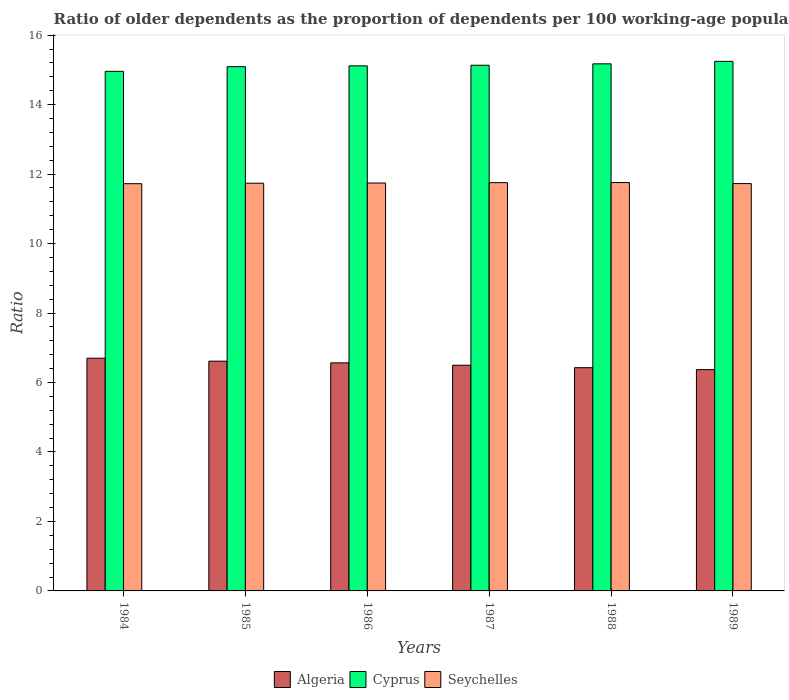How many groups of bars are there?
Offer a terse response. 6. Are the number of bars per tick equal to the number of legend labels?
Your response must be concise. Yes. Are the number of bars on each tick of the X-axis equal?
Provide a short and direct response. Yes. How many bars are there on the 6th tick from the right?
Provide a succinct answer. 3. What is the label of the 1st group of bars from the left?
Offer a terse response. 1984. In how many cases, is the number of bars for a given year not equal to the number of legend labels?
Your response must be concise. 0. What is the age dependency ratio(old) in Seychelles in 1989?
Your answer should be very brief. 11.73. Across all years, what is the maximum age dependency ratio(old) in Seychelles?
Provide a short and direct response. 11.76. Across all years, what is the minimum age dependency ratio(old) in Algeria?
Provide a succinct answer. 6.37. In which year was the age dependency ratio(old) in Cyprus maximum?
Offer a very short reply. 1989. What is the total age dependency ratio(old) in Cyprus in the graph?
Offer a very short reply. 90.72. What is the difference between the age dependency ratio(old) in Seychelles in 1985 and that in 1988?
Keep it short and to the point. -0.02. What is the difference between the age dependency ratio(old) in Seychelles in 1987 and the age dependency ratio(old) in Cyprus in 1985?
Make the answer very short. -3.34. What is the average age dependency ratio(old) in Seychelles per year?
Provide a succinct answer. 11.74. In the year 1989, what is the difference between the age dependency ratio(old) in Seychelles and age dependency ratio(old) in Cyprus?
Provide a short and direct response. -3.52. What is the ratio of the age dependency ratio(old) in Cyprus in 1985 to that in 1987?
Your response must be concise. 1. Is the difference between the age dependency ratio(old) in Seychelles in 1988 and 1989 greater than the difference between the age dependency ratio(old) in Cyprus in 1988 and 1989?
Give a very brief answer. Yes. What is the difference between the highest and the second highest age dependency ratio(old) in Algeria?
Offer a terse response. 0.09. What is the difference between the highest and the lowest age dependency ratio(old) in Cyprus?
Your response must be concise. 0.29. In how many years, is the age dependency ratio(old) in Cyprus greater than the average age dependency ratio(old) in Cyprus taken over all years?
Your answer should be compact. 3. Is the sum of the age dependency ratio(old) in Algeria in 1988 and 1989 greater than the maximum age dependency ratio(old) in Cyprus across all years?
Your response must be concise. No. What does the 1st bar from the left in 1988 represents?
Give a very brief answer. Algeria. What does the 1st bar from the right in 1989 represents?
Ensure brevity in your answer.  Seychelles. Does the graph contain any zero values?
Keep it short and to the point. No. Where does the legend appear in the graph?
Your answer should be very brief. Bottom center. How many legend labels are there?
Your response must be concise. 3. What is the title of the graph?
Keep it short and to the point. Ratio of older dependents as the proportion of dependents per 100 working-age population. Does "OECD members" appear as one of the legend labels in the graph?
Offer a very short reply. No. What is the label or title of the X-axis?
Your response must be concise. Years. What is the label or title of the Y-axis?
Offer a terse response. Ratio. What is the Ratio of Algeria in 1984?
Your answer should be compact. 6.7. What is the Ratio of Cyprus in 1984?
Give a very brief answer. 14.96. What is the Ratio in Seychelles in 1984?
Your answer should be very brief. 11.72. What is the Ratio of Algeria in 1985?
Make the answer very short. 6.61. What is the Ratio of Cyprus in 1985?
Offer a very short reply. 15.09. What is the Ratio of Seychelles in 1985?
Keep it short and to the point. 11.74. What is the Ratio of Algeria in 1986?
Your answer should be very brief. 6.57. What is the Ratio in Cyprus in 1986?
Your answer should be compact. 15.12. What is the Ratio in Seychelles in 1986?
Your response must be concise. 11.74. What is the Ratio in Algeria in 1987?
Your answer should be compact. 6.5. What is the Ratio of Cyprus in 1987?
Ensure brevity in your answer.  15.13. What is the Ratio in Seychelles in 1987?
Keep it short and to the point. 11.75. What is the Ratio of Algeria in 1988?
Give a very brief answer. 6.43. What is the Ratio of Cyprus in 1988?
Make the answer very short. 15.17. What is the Ratio in Seychelles in 1988?
Give a very brief answer. 11.76. What is the Ratio of Algeria in 1989?
Your response must be concise. 6.37. What is the Ratio of Cyprus in 1989?
Provide a succinct answer. 15.25. What is the Ratio in Seychelles in 1989?
Make the answer very short. 11.73. Across all years, what is the maximum Ratio in Algeria?
Your answer should be compact. 6.7. Across all years, what is the maximum Ratio in Cyprus?
Make the answer very short. 15.25. Across all years, what is the maximum Ratio in Seychelles?
Provide a succinct answer. 11.76. Across all years, what is the minimum Ratio in Algeria?
Give a very brief answer. 6.37. Across all years, what is the minimum Ratio in Cyprus?
Make the answer very short. 14.96. Across all years, what is the minimum Ratio in Seychelles?
Your answer should be compact. 11.72. What is the total Ratio of Algeria in the graph?
Offer a very short reply. 39.17. What is the total Ratio in Cyprus in the graph?
Make the answer very short. 90.72. What is the total Ratio of Seychelles in the graph?
Provide a short and direct response. 70.44. What is the difference between the Ratio of Algeria in 1984 and that in 1985?
Ensure brevity in your answer.  0.09. What is the difference between the Ratio in Cyprus in 1984 and that in 1985?
Offer a very short reply. -0.13. What is the difference between the Ratio of Seychelles in 1984 and that in 1985?
Your response must be concise. -0.01. What is the difference between the Ratio of Algeria in 1984 and that in 1986?
Provide a succinct answer. 0.13. What is the difference between the Ratio of Cyprus in 1984 and that in 1986?
Your response must be concise. -0.16. What is the difference between the Ratio in Seychelles in 1984 and that in 1986?
Offer a very short reply. -0.02. What is the difference between the Ratio of Algeria in 1984 and that in 1987?
Your answer should be compact. 0.2. What is the difference between the Ratio in Cyprus in 1984 and that in 1987?
Your answer should be compact. -0.18. What is the difference between the Ratio in Seychelles in 1984 and that in 1987?
Your response must be concise. -0.03. What is the difference between the Ratio of Algeria in 1984 and that in 1988?
Make the answer very short. 0.27. What is the difference between the Ratio in Cyprus in 1984 and that in 1988?
Provide a succinct answer. -0.22. What is the difference between the Ratio in Seychelles in 1984 and that in 1988?
Offer a very short reply. -0.03. What is the difference between the Ratio in Algeria in 1984 and that in 1989?
Make the answer very short. 0.33. What is the difference between the Ratio of Cyprus in 1984 and that in 1989?
Provide a short and direct response. -0.29. What is the difference between the Ratio of Seychelles in 1984 and that in 1989?
Your answer should be very brief. -0. What is the difference between the Ratio of Algeria in 1985 and that in 1986?
Keep it short and to the point. 0.05. What is the difference between the Ratio in Cyprus in 1985 and that in 1986?
Your answer should be very brief. -0.02. What is the difference between the Ratio of Seychelles in 1985 and that in 1986?
Keep it short and to the point. -0.01. What is the difference between the Ratio of Algeria in 1985 and that in 1987?
Your response must be concise. 0.12. What is the difference between the Ratio in Cyprus in 1985 and that in 1987?
Ensure brevity in your answer.  -0.04. What is the difference between the Ratio in Seychelles in 1985 and that in 1987?
Keep it short and to the point. -0.02. What is the difference between the Ratio in Algeria in 1985 and that in 1988?
Offer a terse response. 0.19. What is the difference between the Ratio in Cyprus in 1985 and that in 1988?
Provide a short and direct response. -0.08. What is the difference between the Ratio of Seychelles in 1985 and that in 1988?
Your answer should be compact. -0.02. What is the difference between the Ratio of Algeria in 1985 and that in 1989?
Provide a short and direct response. 0.24. What is the difference between the Ratio of Cyprus in 1985 and that in 1989?
Keep it short and to the point. -0.15. What is the difference between the Ratio in Seychelles in 1985 and that in 1989?
Offer a terse response. 0.01. What is the difference between the Ratio in Algeria in 1986 and that in 1987?
Provide a short and direct response. 0.07. What is the difference between the Ratio of Cyprus in 1986 and that in 1987?
Make the answer very short. -0.02. What is the difference between the Ratio in Seychelles in 1986 and that in 1987?
Keep it short and to the point. -0.01. What is the difference between the Ratio in Algeria in 1986 and that in 1988?
Your answer should be very brief. 0.14. What is the difference between the Ratio of Cyprus in 1986 and that in 1988?
Make the answer very short. -0.06. What is the difference between the Ratio of Seychelles in 1986 and that in 1988?
Make the answer very short. -0.01. What is the difference between the Ratio of Algeria in 1986 and that in 1989?
Ensure brevity in your answer.  0.19. What is the difference between the Ratio of Cyprus in 1986 and that in 1989?
Ensure brevity in your answer.  -0.13. What is the difference between the Ratio of Seychelles in 1986 and that in 1989?
Offer a very short reply. 0.02. What is the difference between the Ratio in Algeria in 1987 and that in 1988?
Ensure brevity in your answer.  0.07. What is the difference between the Ratio in Cyprus in 1987 and that in 1988?
Offer a very short reply. -0.04. What is the difference between the Ratio of Seychelles in 1987 and that in 1988?
Your response must be concise. -0. What is the difference between the Ratio of Algeria in 1987 and that in 1989?
Your answer should be compact. 0.13. What is the difference between the Ratio of Cyprus in 1987 and that in 1989?
Provide a short and direct response. -0.11. What is the difference between the Ratio of Seychelles in 1987 and that in 1989?
Provide a succinct answer. 0.03. What is the difference between the Ratio in Algeria in 1988 and that in 1989?
Ensure brevity in your answer.  0.06. What is the difference between the Ratio of Cyprus in 1988 and that in 1989?
Give a very brief answer. -0.07. What is the difference between the Ratio of Seychelles in 1988 and that in 1989?
Give a very brief answer. 0.03. What is the difference between the Ratio in Algeria in 1984 and the Ratio in Cyprus in 1985?
Provide a succinct answer. -8.39. What is the difference between the Ratio of Algeria in 1984 and the Ratio of Seychelles in 1985?
Provide a succinct answer. -5.04. What is the difference between the Ratio of Cyprus in 1984 and the Ratio of Seychelles in 1985?
Provide a short and direct response. 3.22. What is the difference between the Ratio in Algeria in 1984 and the Ratio in Cyprus in 1986?
Offer a terse response. -8.42. What is the difference between the Ratio of Algeria in 1984 and the Ratio of Seychelles in 1986?
Your answer should be very brief. -5.04. What is the difference between the Ratio in Cyprus in 1984 and the Ratio in Seychelles in 1986?
Provide a short and direct response. 3.22. What is the difference between the Ratio in Algeria in 1984 and the Ratio in Cyprus in 1987?
Your response must be concise. -8.43. What is the difference between the Ratio in Algeria in 1984 and the Ratio in Seychelles in 1987?
Provide a short and direct response. -5.05. What is the difference between the Ratio in Cyprus in 1984 and the Ratio in Seychelles in 1987?
Make the answer very short. 3.2. What is the difference between the Ratio of Algeria in 1984 and the Ratio of Cyprus in 1988?
Offer a terse response. -8.47. What is the difference between the Ratio in Algeria in 1984 and the Ratio in Seychelles in 1988?
Your response must be concise. -5.06. What is the difference between the Ratio of Cyprus in 1984 and the Ratio of Seychelles in 1988?
Offer a very short reply. 3.2. What is the difference between the Ratio in Algeria in 1984 and the Ratio in Cyprus in 1989?
Offer a terse response. -8.55. What is the difference between the Ratio of Algeria in 1984 and the Ratio of Seychelles in 1989?
Your response must be concise. -5.03. What is the difference between the Ratio in Cyprus in 1984 and the Ratio in Seychelles in 1989?
Provide a succinct answer. 3.23. What is the difference between the Ratio in Algeria in 1985 and the Ratio in Cyprus in 1986?
Ensure brevity in your answer.  -8.5. What is the difference between the Ratio of Algeria in 1985 and the Ratio of Seychelles in 1986?
Provide a short and direct response. -5.13. What is the difference between the Ratio in Cyprus in 1985 and the Ratio in Seychelles in 1986?
Offer a very short reply. 3.35. What is the difference between the Ratio of Algeria in 1985 and the Ratio of Cyprus in 1987?
Provide a short and direct response. -8.52. What is the difference between the Ratio in Algeria in 1985 and the Ratio in Seychelles in 1987?
Your response must be concise. -5.14. What is the difference between the Ratio of Cyprus in 1985 and the Ratio of Seychelles in 1987?
Provide a short and direct response. 3.34. What is the difference between the Ratio in Algeria in 1985 and the Ratio in Cyprus in 1988?
Give a very brief answer. -8.56. What is the difference between the Ratio of Algeria in 1985 and the Ratio of Seychelles in 1988?
Offer a terse response. -5.14. What is the difference between the Ratio in Cyprus in 1985 and the Ratio in Seychelles in 1988?
Your response must be concise. 3.34. What is the difference between the Ratio in Algeria in 1985 and the Ratio in Cyprus in 1989?
Ensure brevity in your answer.  -8.63. What is the difference between the Ratio of Algeria in 1985 and the Ratio of Seychelles in 1989?
Offer a terse response. -5.11. What is the difference between the Ratio in Cyprus in 1985 and the Ratio in Seychelles in 1989?
Ensure brevity in your answer.  3.37. What is the difference between the Ratio of Algeria in 1986 and the Ratio of Cyprus in 1987?
Keep it short and to the point. -8.57. What is the difference between the Ratio of Algeria in 1986 and the Ratio of Seychelles in 1987?
Offer a terse response. -5.19. What is the difference between the Ratio in Cyprus in 1986 and the Ratio in Seychelles in 1987?
Keep it short and to the point. 3.36. What is the difference between the Ratio of Algeria in 1986 and the Ratio of Cyprus in 1988?
Keep it short and to the point. -8.61. What is the difference between the Ratio of Algeria in 1986 and the Ratio of Seychelles in 1988?
Your answer should be very brief. -5.19. What is the difference between the Ratio of Cyprus in 1986 and the Ratio of Seychelles in 1988?
Your answer should be very brief. 3.36. What is the difference between the Ratio of Algeria in 1986 and the Ratio of Cyprus in 1989?
Keep it short and to the point. -8.68. What is the difference between the Ratio of Algeria in 1986 and the Ratio of Seychelles in 1989?
Offer a very short reply. -5.16. What is the difference between the Ratio of Cyprus in 1986 and the Ratio of Seychelles in 1989?
Offer a terse response. 3.39. What is the difference between the Ratio of Algeria in 1987 and the Ratio of Cyprus in 1988?
Offer a terse response. -8.68. What is the difference between the Ratio in Algeria in 1987 and the Ratio in Seychelles in 1988?
Give a very brief answer. -5.26. What is the difference between the Ratio in Cyprus in 1987 and the Ratio in Seychelles in 1988?
Offer a very short reply. 3.38. What is the difference between the Ratio of Algeria in 1987 and the Ratio of Cyprus in 1989?
Give a very brief answer. -8.75. What is the difference between the Ratio in Algeria in 1987 and the Ratio in Seychelles in 1989?
Provide a succinct answer. -5.23. What is the difference between the Ratio of Cyprus in 1987 and the Ratio of Seychelles in 1989?
Provide a short and direct response. 3.41. What is the difference between the Ratio of Algeria in 1988 and the Ratio of Cyprus in 1989?
Your answer should be very brief. -8.82. What is the difference between the Ratio of Algeria in 1988 and the Ratio of Seychelles in 1989?
Your answer should be very brief. -5.3. What is the difference between the Ratio of Cyprus in 1988 and the Ratio of Seychelles in 1989?
Your response must be concise. 3.45. What is the average Ratio of Algeria per year?
Provide a succinct answer. 6.53. What is the average Ratio of Cyprus per year?
Keep it short and to the point. 15.12. What is the average Ratio of Seychelles per year?
Your answer should be compact. 11.74. In the year 1984, what is the difference between the Ratio in Algeria and Ratio in Cyprus?
Give a very brief answer. -8.26. In the year 1984, what is the difference between the Ratio in Algeria and Ratio in Seychelles?
Your answer should be compact. -5.02. In the year 1984, what is the difference between the Ratio in Cyprus and Ratio in Seychelles?
Keep it short and to the point. 3.23. In the year 1985, what is the difference between the Ratio of Algeria and Ratio of Cyprus?
Your answer should be compact. -8.48. In the year 1985, what is the difference between the Ratio in Algeria and Ratio in Seychelles?
Your response must be concise. -5.12. In the year 1985, what is the difference between the Ratio of Cyprus and Ratio of Seychelles?
Your answer should be compact. 3.36. In the year 1986, what is the difference between the Ratio in Algeria and Ratio in Cyprus?
Keep it short and to the point. -8.55. In the year 1986, what is the difference between the Ratio of Algeria and Ratio of Seychelles?
Offer a very short reply. -5.18. In the year 1986, what is the difference between the Ratio of Cyprus and Ratio of Seychelles?
Your answer should be compact. 3.37. In the year 1987, what is the difference between the Ratio of Algeria and Ratio of Cyprus?
Provide a succinct answer. -8.64. In the year 1987, what is the difference between the Ratio of Algeria and Ratio of Seychelles?
Your answer should be very brief. -5.26. In the year 1987, what is the difference between the Ratio of Cyprus and Ratio of Seychelles?
Make the answer very short. 3.38. In the year 1988, what is the difference between the Ratio in Algeria and Ratio in Cyprus?
Your answer should be very brief. -8.75. In the year 1988, what is the difference between the Ratio in Algeria and Ratio in Seychelles?
Your response must be concise. -5.33. In the year 1988, what is the difference between the Ratio of Cyprus and Ratio of Seychelles?
Provide a short and direct response. 3.42. In the year 1989, what is the difference between the Ratio of Algeria and Ratio of Cyprus?
Ensure brevity in your answer.  -8.87. In the year 1989, what is the difference between the Ratio of Algeria and Ratio of Seychelles?
Provide a succinct answer. -5.35. In the year 1989, what is the difference between the Ratio of Cyprus and Ratio of Seychelles?
Provide a short and direct response. 3.52. What is the ratio of the Ratio of Algeria in 1984 to that in 1985?
Give a very brief answer. 1.01. What is the ratio of the Ratio in Algeria in 1984 to that in 1986?
Offer a terse response. 1.02. What is the ratio of the Ratio in Cyprus in 1984 to that in 1986?
Keep it short and to the point. 0.99. What is the ratio of the Ratio in Algeria in 1984 to that in 1987?
Keep it short and to the point. 1.03. What is the ratio of the Ratio in Cyprus in 1984 to that in 1987?
Your answer should be very brief. 0.99. What is the ratio of the Ratio in Algeria in 1984 to that in 1988?
Provide a short and direct response. 1.04. What is the ratio of the Ratio of Cyprus in 1984 to that in 1988?
Keep it short and to the point. 0.99. What is the ratio of the Ratio in Seychelles in 1984 to that in 1988?
Your answer should be compact. 1. What is the ratio of the Ratio of Algeria in 1984 to that in 1989?
Ensure brevity in your answer.  1.05. What is the ratio of the Ratio of Cyprus in 1984 to that in 1989?
Make the answer very short. 0.98. What is the ratio of the Ratio of Algeria in 1985 to that in 1986?
Provide a short and direct response. 1.01. What is the ratio of the Ratio in Cyprus in 1985 to that in 1986?
Give a very brief answer. 1. What is the ratio of the Ratio in Seychelles in 1985 to that in 1986?
Provide a succinct answer. 1. What is the ratio of the Ratio of Seychelles in 1985 to that in 1987?
Your answer should be compact. 1. What is the ratio of the Ratio in Algeria in 1985 to that in 1988?
Your answer should be very brief. 1.03. What is the ratio of the Ratio of Cyprus in 1985 to that in 1988?
Your answer should be very brief. 0.99. What is the ratio of the Ratio of Seychelles in 1985 to that in 1988?
Your answer should be compact. 1. What is the ratio of the Ratio of Algeria in 1985 to that in 1989?
Offer a terse response. 1.04. What is the ratio of the Ratio in Algeria in 1986 to that in 1987?
Offer a very short reply. 1.01. What is the ratio of the Ratio in Cyprus in 1986 to that in 1987?
Ensure brevity in your answer.  1. What is the ratio of the Ratio in Algeria in 1986 to that in 1988?
Offer a terse response. 1.02. What is the ratio of the Ratio in Cyprus in 1986 to that in 1988?
Give a very brief answer. 1. What is the ratio of the Ratio in Algeria in 1986 to that in 1989?
Your answer should be compact. 1.03. What is the ratio of the Ratio in Cyprus in 1986 to that in 1989?
Give a very brief answer. 0.99. What is the ratio of the Ratio of Algeria in 1987 to that in 1988?
Your answer should be very brief. 1.01. What is the ratio of the Ratio in Cyprus in 1987 to that in 1988?
Give a very brief answer. 1. What is the ratio of the Ratio in Seychelles in 1987 to that in 1988?
Provide a succinct answer. 1. What is the ratio of the Ratio in Algeria in 1987 to that in 1989?
Give a very brief answer. 1.02. What is the ratio of the Ratio in Cyprus in 1987 to that in 1989?
Keep it short and to the point. 0.99. What is the ratio of the Ratio in Algeria in 1988 to that in 1989?
Ensure brevity in your answer.  1.01. What is the ratio of the Ratio in Seychelles in 1988 to that in 1989?
Offer a very short reply. 1. What is the difference between the highest and the second highest Ratio in Algeria?
Offer a terse response. 0.09. What is the difference between the highest and the second highest Ratio in Cyprus?
Ensure brevity in your answer.  0.07. What is the difference between the highest and the second highest Ratio in Seychelles?
Your answer should be compact. 0. What is the difference between the highest and the lowest Ratio of Algeria?
Offer a terse response. 0.33. What is the difference between the highest and the lowest Ratio of Cyprus?
Offer a very short reply. 0.29. What is the difference between the highest and the lowest Ratio of Seychelles?
Give a very brief answer. 0.03. 